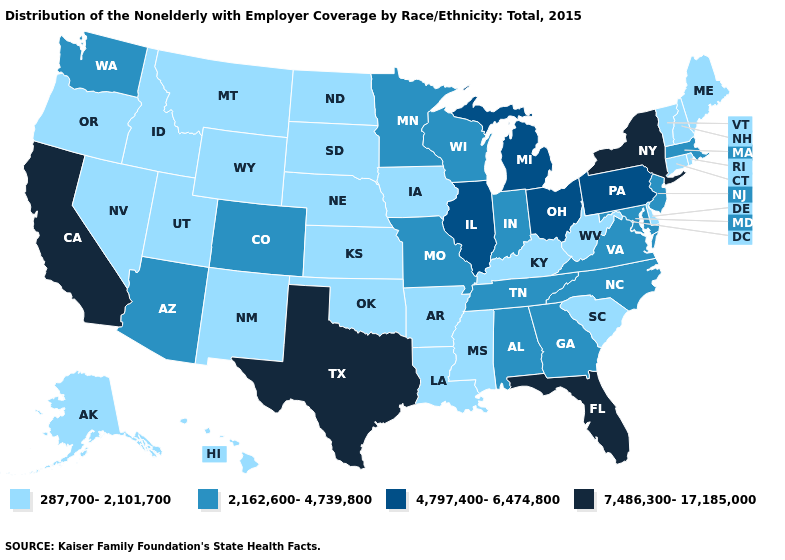Does Oklahoma have the same value as Arizona?
Concise answer only. No. What is the lowest value in the USA?
Answer briefly. 287,700-2,101,700. Name the states that have a value in the range 4,797,400-6,474,800?
Give a very brief answer. Illinois, Michigan, Ohio, Pennsylvania. What is the highest value in states that border Ohio?
Write a very short answer. 4,797,400-6,474,800. What is the highest value in states that border New Jersey?
Short answer required. 7,486,300-17,185,000. What is the value of Michigan?
Quick response, please. 4,797,400-6,474,800. What is the value of Maine?
Write a very short answer. 287,700-2,101,700. What is the lowest value in the South?
Quick response, please. 287,700-2,101,700. What is the lowest value in the USA?
Be succinct. 287,700-2,101,700. Does Delaware have the same value as California?
Concise answer only. No. What is the lowest value in the USA?
Be succinct. 287,700-2,101,700. Does Kentucky have the same value as Hawaii?
Short answer required. Yes. Which states have the lowest value in the MidWest?
Keep it brief. Iowa, Kansas, Nebraska, North Dakota, South Dakota. Does Arizona have the lowest value in the USA?
Short answer required. No. What is the value of Illinois?
Concise answer only. 4,797,400-6,474,800. 